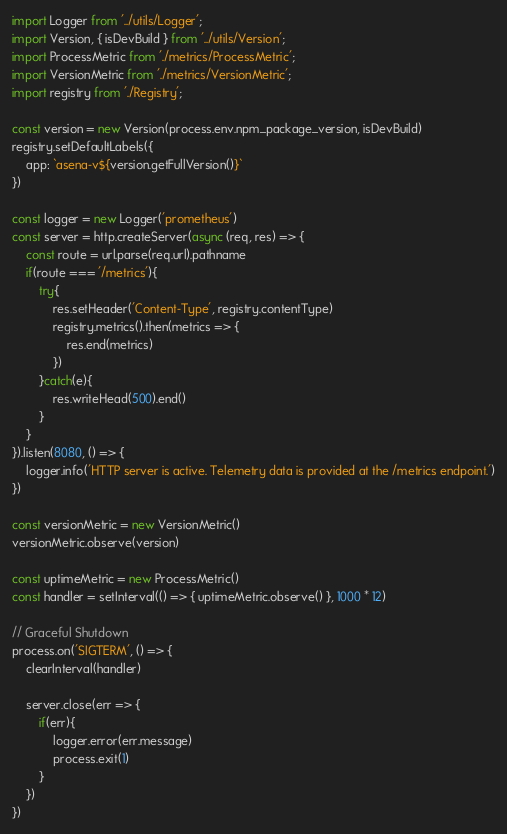Convert code to text. <code><loc_0><loc_0><loc_500><loc_500><_TypeScript_>import Logger from '../utils/Logger';
import Version, { isDevBuild } from '../utils/Version';
import ProcessMetric from './metrics/ProcessMetric';
import VersionMetric from './metrics/VersionMetric';
import registry from './Registry';

const version = new Version(process.env.npm_package_version, isDevBuild)
registry.setDefaultLabels({
    app: `asena-v${version.getFullVersion()}`
})

const logger = new Logger('prometheus')
const server = http.createServer(async (req, res) => {
    const route = url.parse(req.url).pathname
    if(route === '/metrics'){
        try{
            res.setHeader('Content-Type', registry.contentType)
            registry.metrics().then(metrics => {
                res.end(metrics)
            })
        }catch(e){
            res.writeHead(500).end()
        }
    }
}).listen(8080, () => {
    logger.info('HTTP server is active. Telemetry data is provided at the /metrics endpoint.')
})

const versionMetric = new VersionMetric()
versionMetric.observe(version)

const uptimeMetric = new ProcessMetric()
const handler = setInterval(() => { uptimeMetric.observe() }, 1000 * 12)

// Graceful Shutdown
process.on('SIGTERM', () => {
    clearInterval(handler)

    server.close(err => {
        if(err){
            logger.error(err.message)
            process.exit(1)
        }
    })
})
</code> 